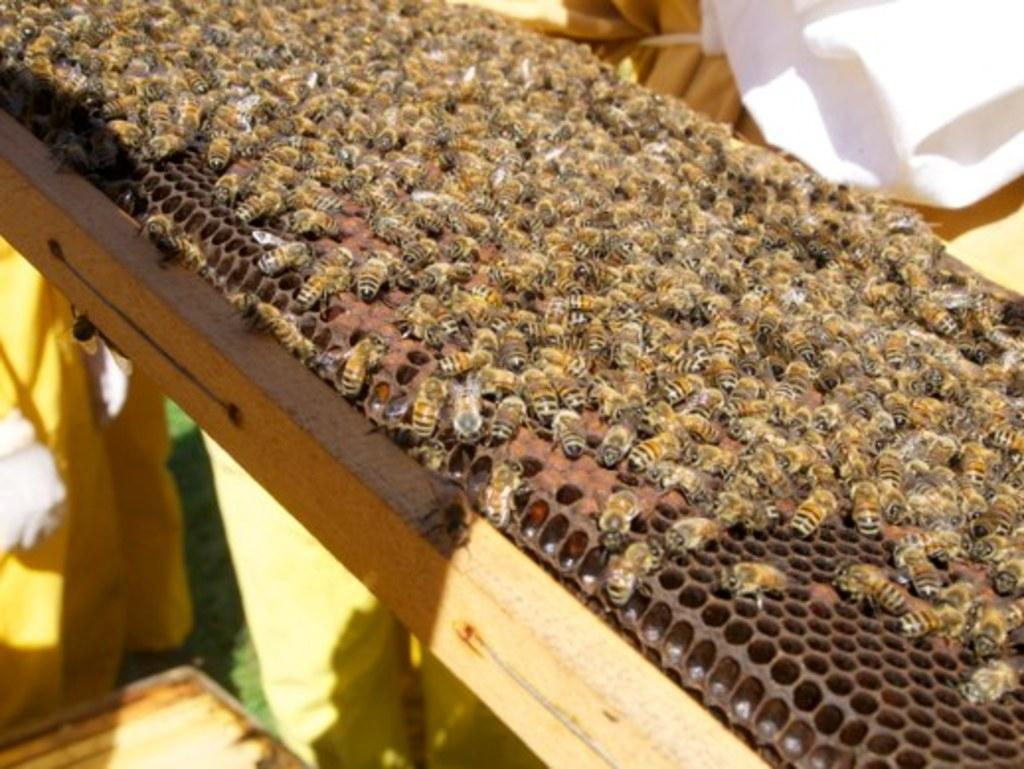What type of insects can be seen in the image? There are honey bees in the image. What structure is visible in the middle of the image? There is a honeycomb in the middle of the image. What type of mineral can be seen in the image? There is no mineral present in the image; it features honey bees and a honeycomb. How does the balance of the honeycomb appear in the image? The image does not show the balance of the honeycomb; it only shows the honeycomb itself. 